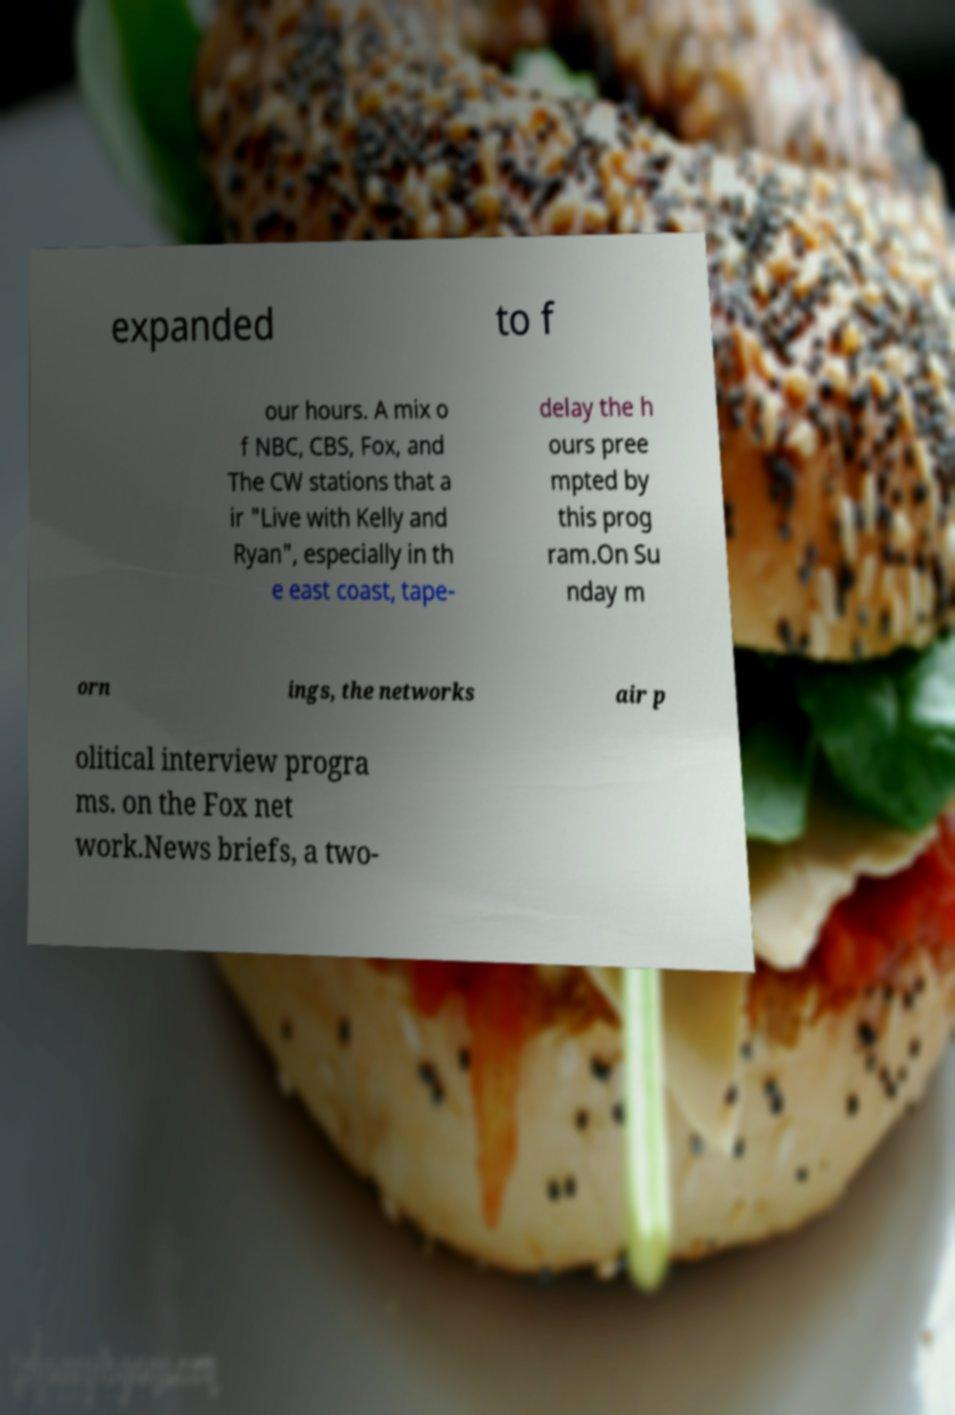For documentation purposes, I need the text within this image transcribed. Could you provide that? expanded to f our hours. A mix o f NBC, CBS, Fox, and The CW stations that a ir "Live with Kelly and Ryan", especially in th e east coast, tape- delay the h ours pree mpted by this prog ram.On Su nday m orn ings, the networks air p olitical interview progra ms. on the Fox net work.News briefs, a two- 